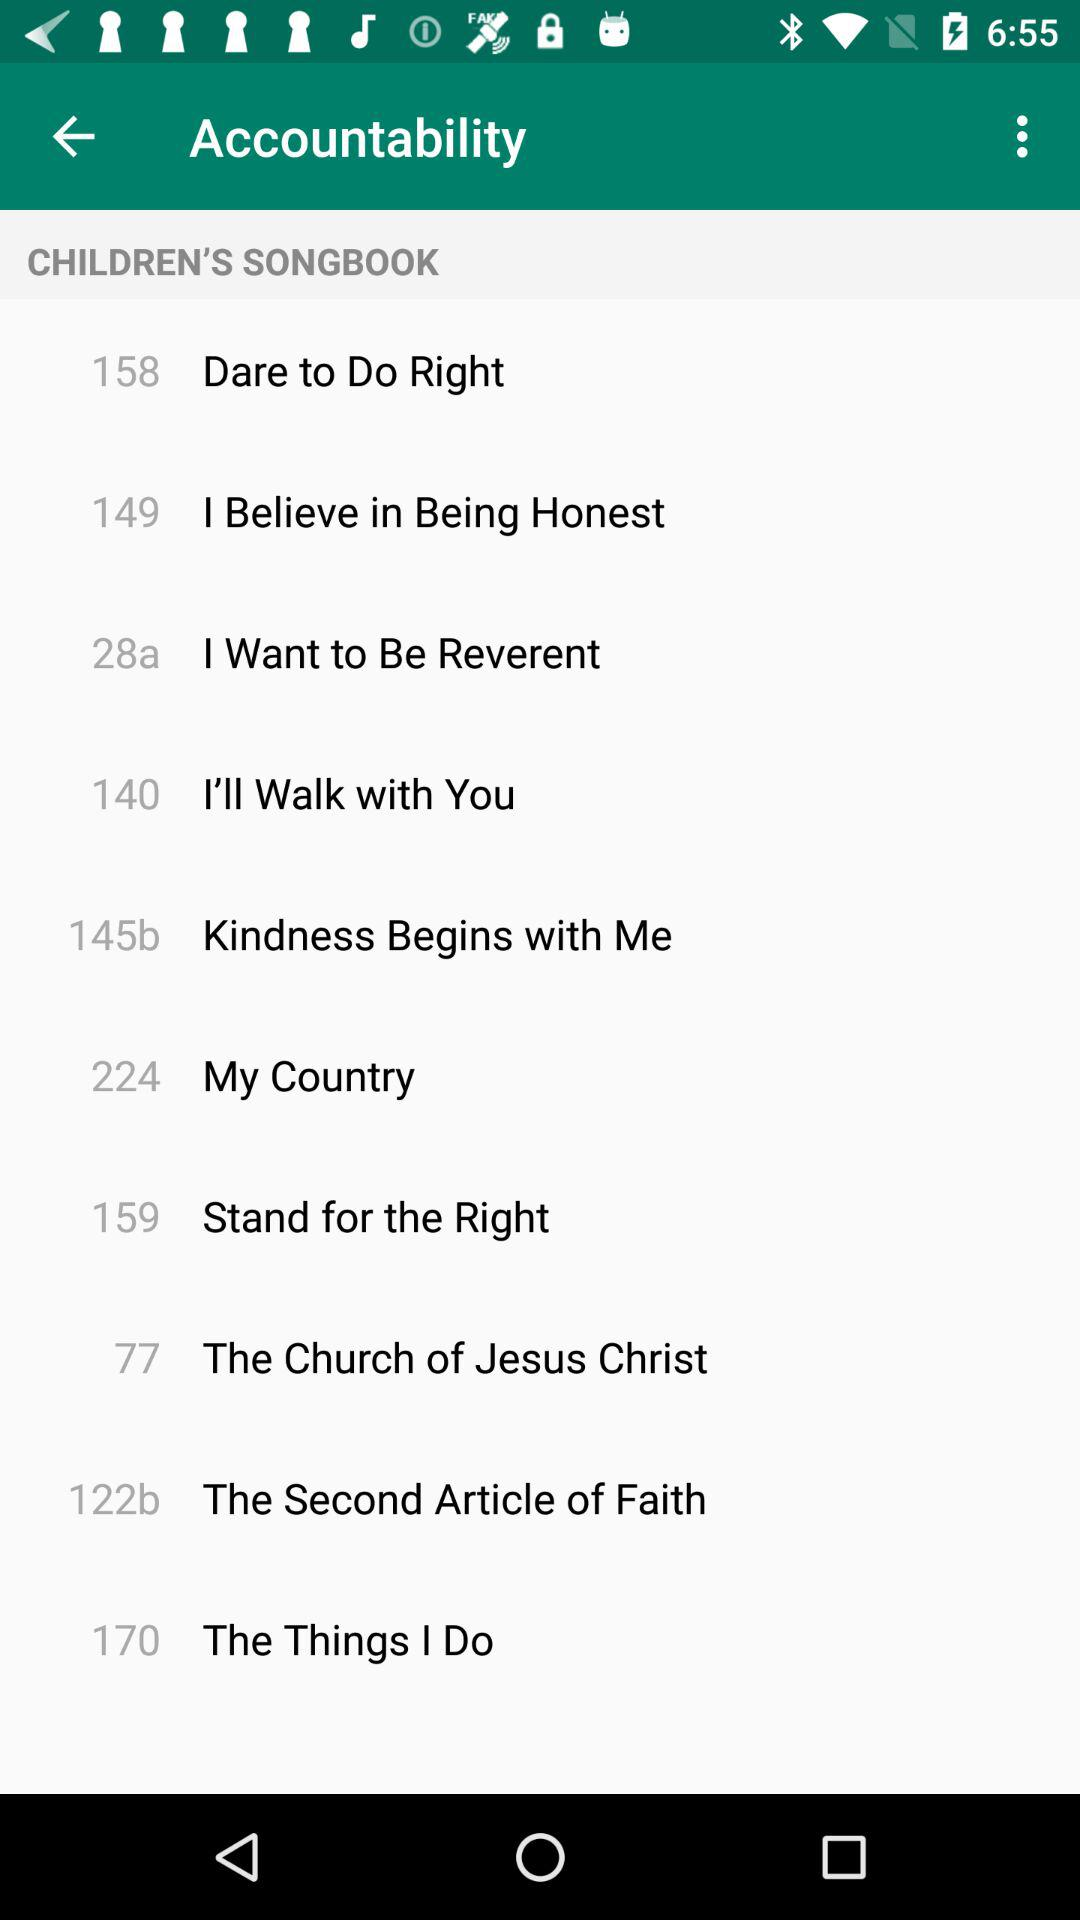Which are the different songs? The songs are "Dare to Do Right", "I Believe in Being Honest", "I Want to Be Reverent", "I'll Walk with You", "Kindness Begins with Me", "My Country", "Stand for the Right", "The Church of Jesus Christ", "The Second Article of Faith" and "The Things I Do". 